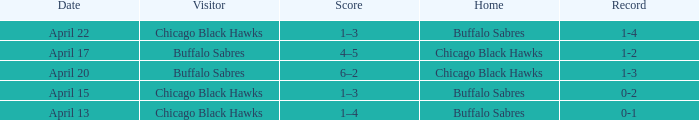When has a Record of 1-3? April 20. 